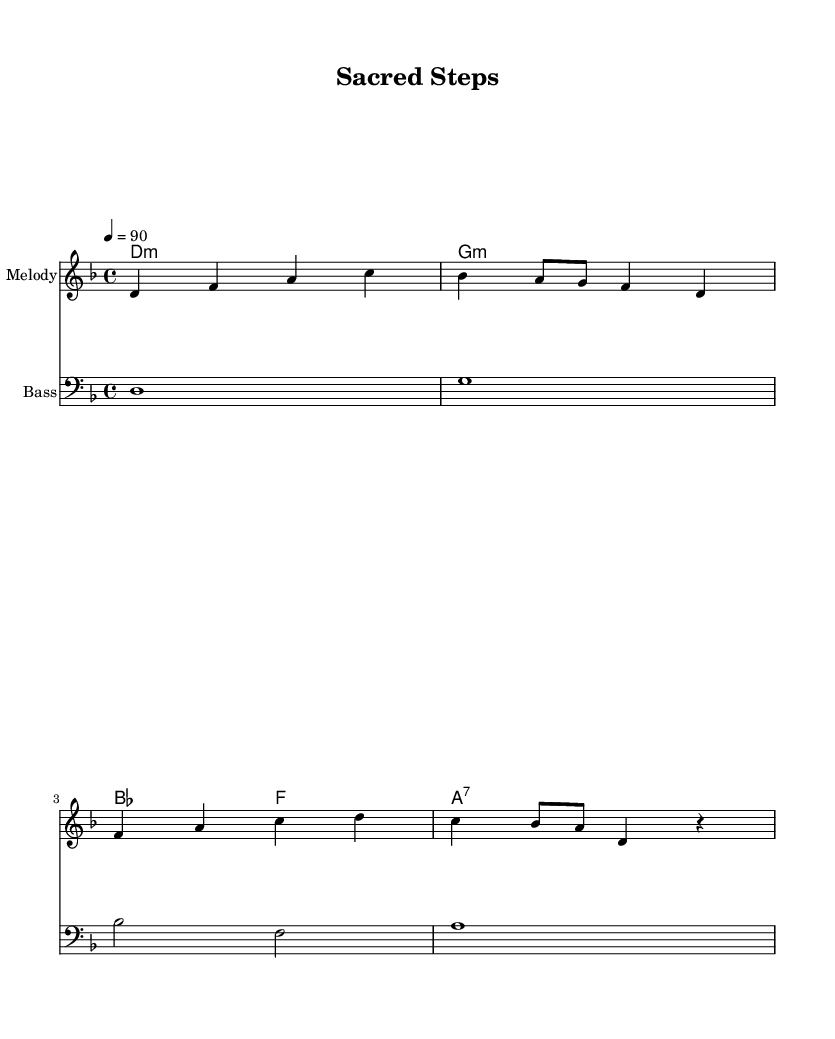What is the key signature of this music? The key signature is D minor, which includes one flat (B flat). This can be found at the beginning of the staff where the key signature symbols are placed.
Answer: D minor What is the time signature of this music? The time signature is 4/4, indicated at the beginning of the score. This means there are four beats per measure and a quarter note receives one beat.
Answer: 4/4 What is the tempo marking for this piece? The tempo marking is 90 beats per minute, denoted by "4 = 90," which provides the speed at which the piece should be played.
Answer: 90 How many measures are presented in the melody? The melody contains four measures, which can be counted by observing the vertical bar lines that separate each measure.
Answer: 4 What type of chords are used in the harmonies section? The chords indicated are minor and seventh chords, as seen in the symbols used (e.g., "d1:m," "a1:7"). This shows the flavor and texture of the harmony.
Answer: Minor and seventh What is the instrument name for the melody staff? The instrument name indicated for the melody staff is "Melody," which identifies the type of sound that this particular staff is meant to produce.
Answer: Melody What is the relationship between the bass and melody in this piece? The bass provides a harmonic foundation that supports the melody, evident through the corresponding bass notes played alongside the melody notes. This interaction is crucial in rap for rhythmic and tonal balance.
Answer: Harmonic foundation 